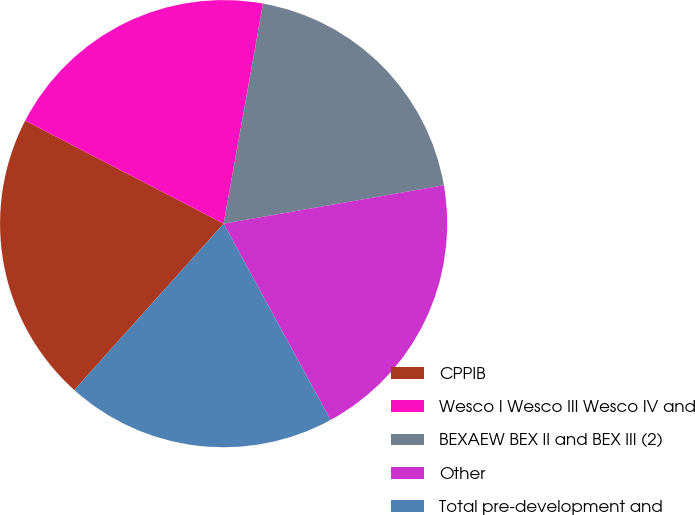<chart> <loc_0><loc_0><loc_500><loc_500><pie_chart><fcel>CPPIB<fcel>Wesco I Wesco III Wesco IV and<fcel>BEXAEW BEX II and BEX III (2)<fcel>Other<fcel>Total pre-development and<nl><fcel>20.98%<fcel>20.2%<fcel>19.43%<fcel>19.81%<fcel>19.58%<nl></chart> 